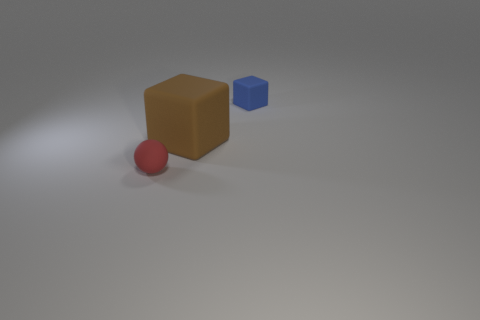Do the red matte object and the matte block left of the blue block have the same size?
Provide a short and direct response. No. What number of red balls have the same material as the big block?
Your answer should be very brief. 1. Are any purple metal balls visible?
Make the answer very short. No. How many rubber things have the same color as the tiny rubber sphere?
Keep it short and to the point. 0. Are there more small rubber objects in front of the blue rubber thing than tiny yellow balls?
Your answer should be very brief. Yes. Is there anything else that is the same size as the brown block?
Ensure brevity in your answer.  No. There is a large rubber object; is it the same color as the small rubber thing that is on the right side of the big brown object?
Offer a very short reply. No. Are there the same number of large things that are on the right side of the big matte thing and small red rubber balls that are right of the small blue cube?
Provide a succinct answer. Yes. How many objects are either matte things that are behind the red ball or red shiny balls?
Offer a very short reply. 2. How many other objects are the same shape as the tiny blue rubber object?
Your response must be concise. 1. 